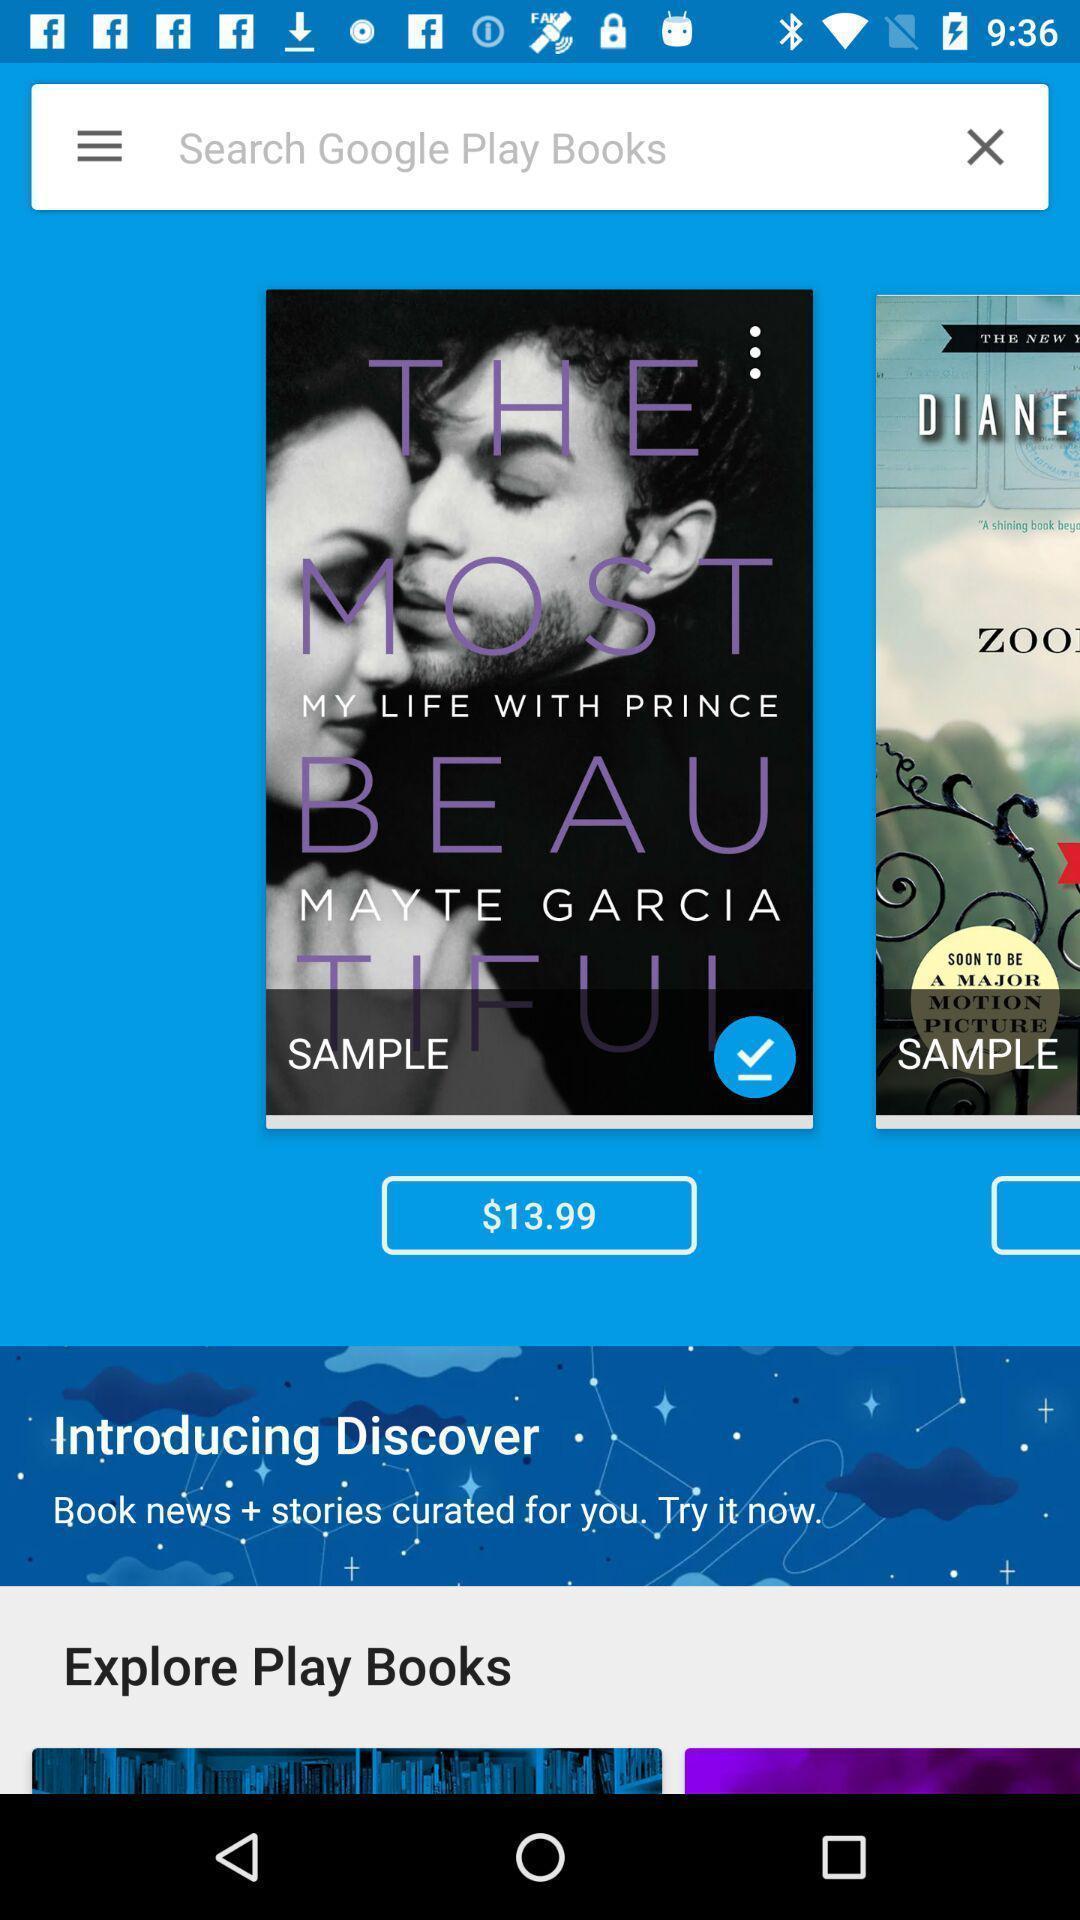Explain what's happening in this screen capture. Search bar to search for the book from social app. 